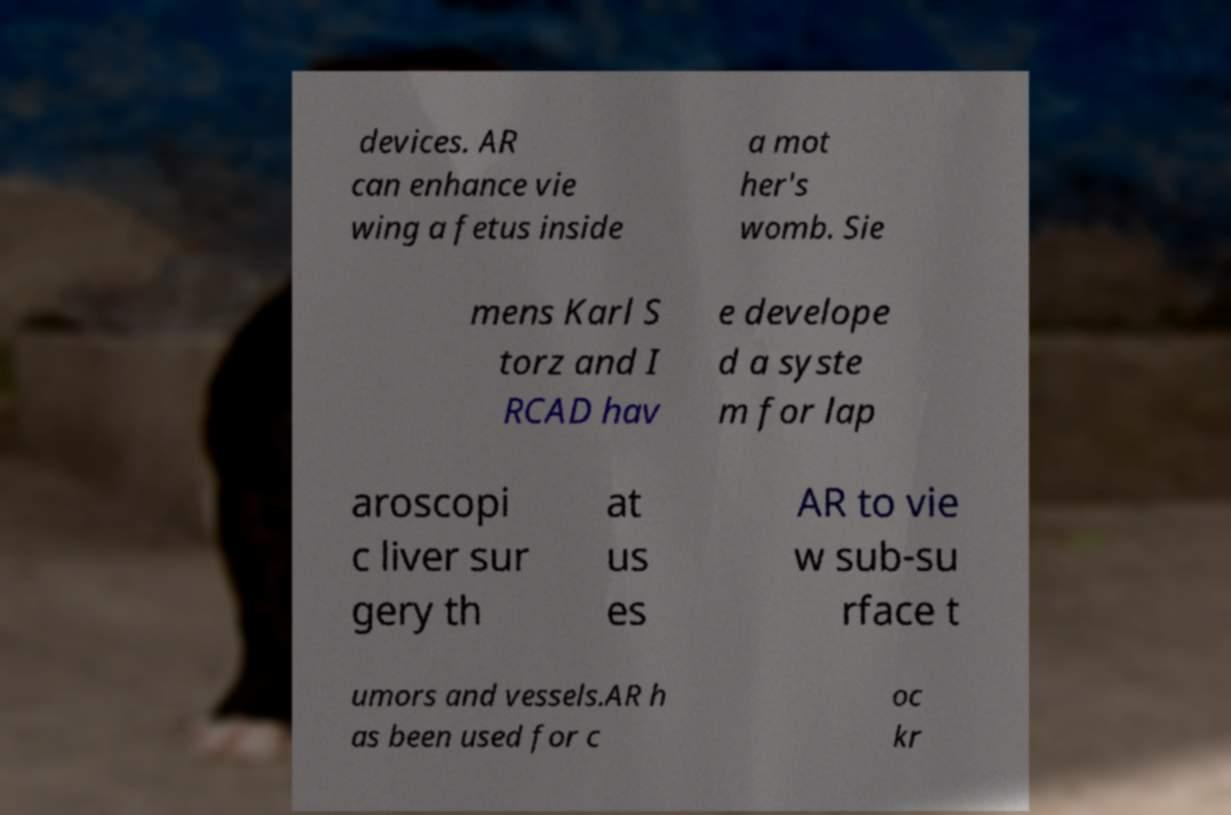Could you extract and type out the text from this image? devices. AR can enhance vie wing a fetus inside a mot her's womb. Sie mens Karl S torz and I RCAD hav e develope d a syste m for lap aroscopi c liver sur gery th at us es AR to vie w sub-su rface t umors and vessels.AR h as been used for c oc kr 